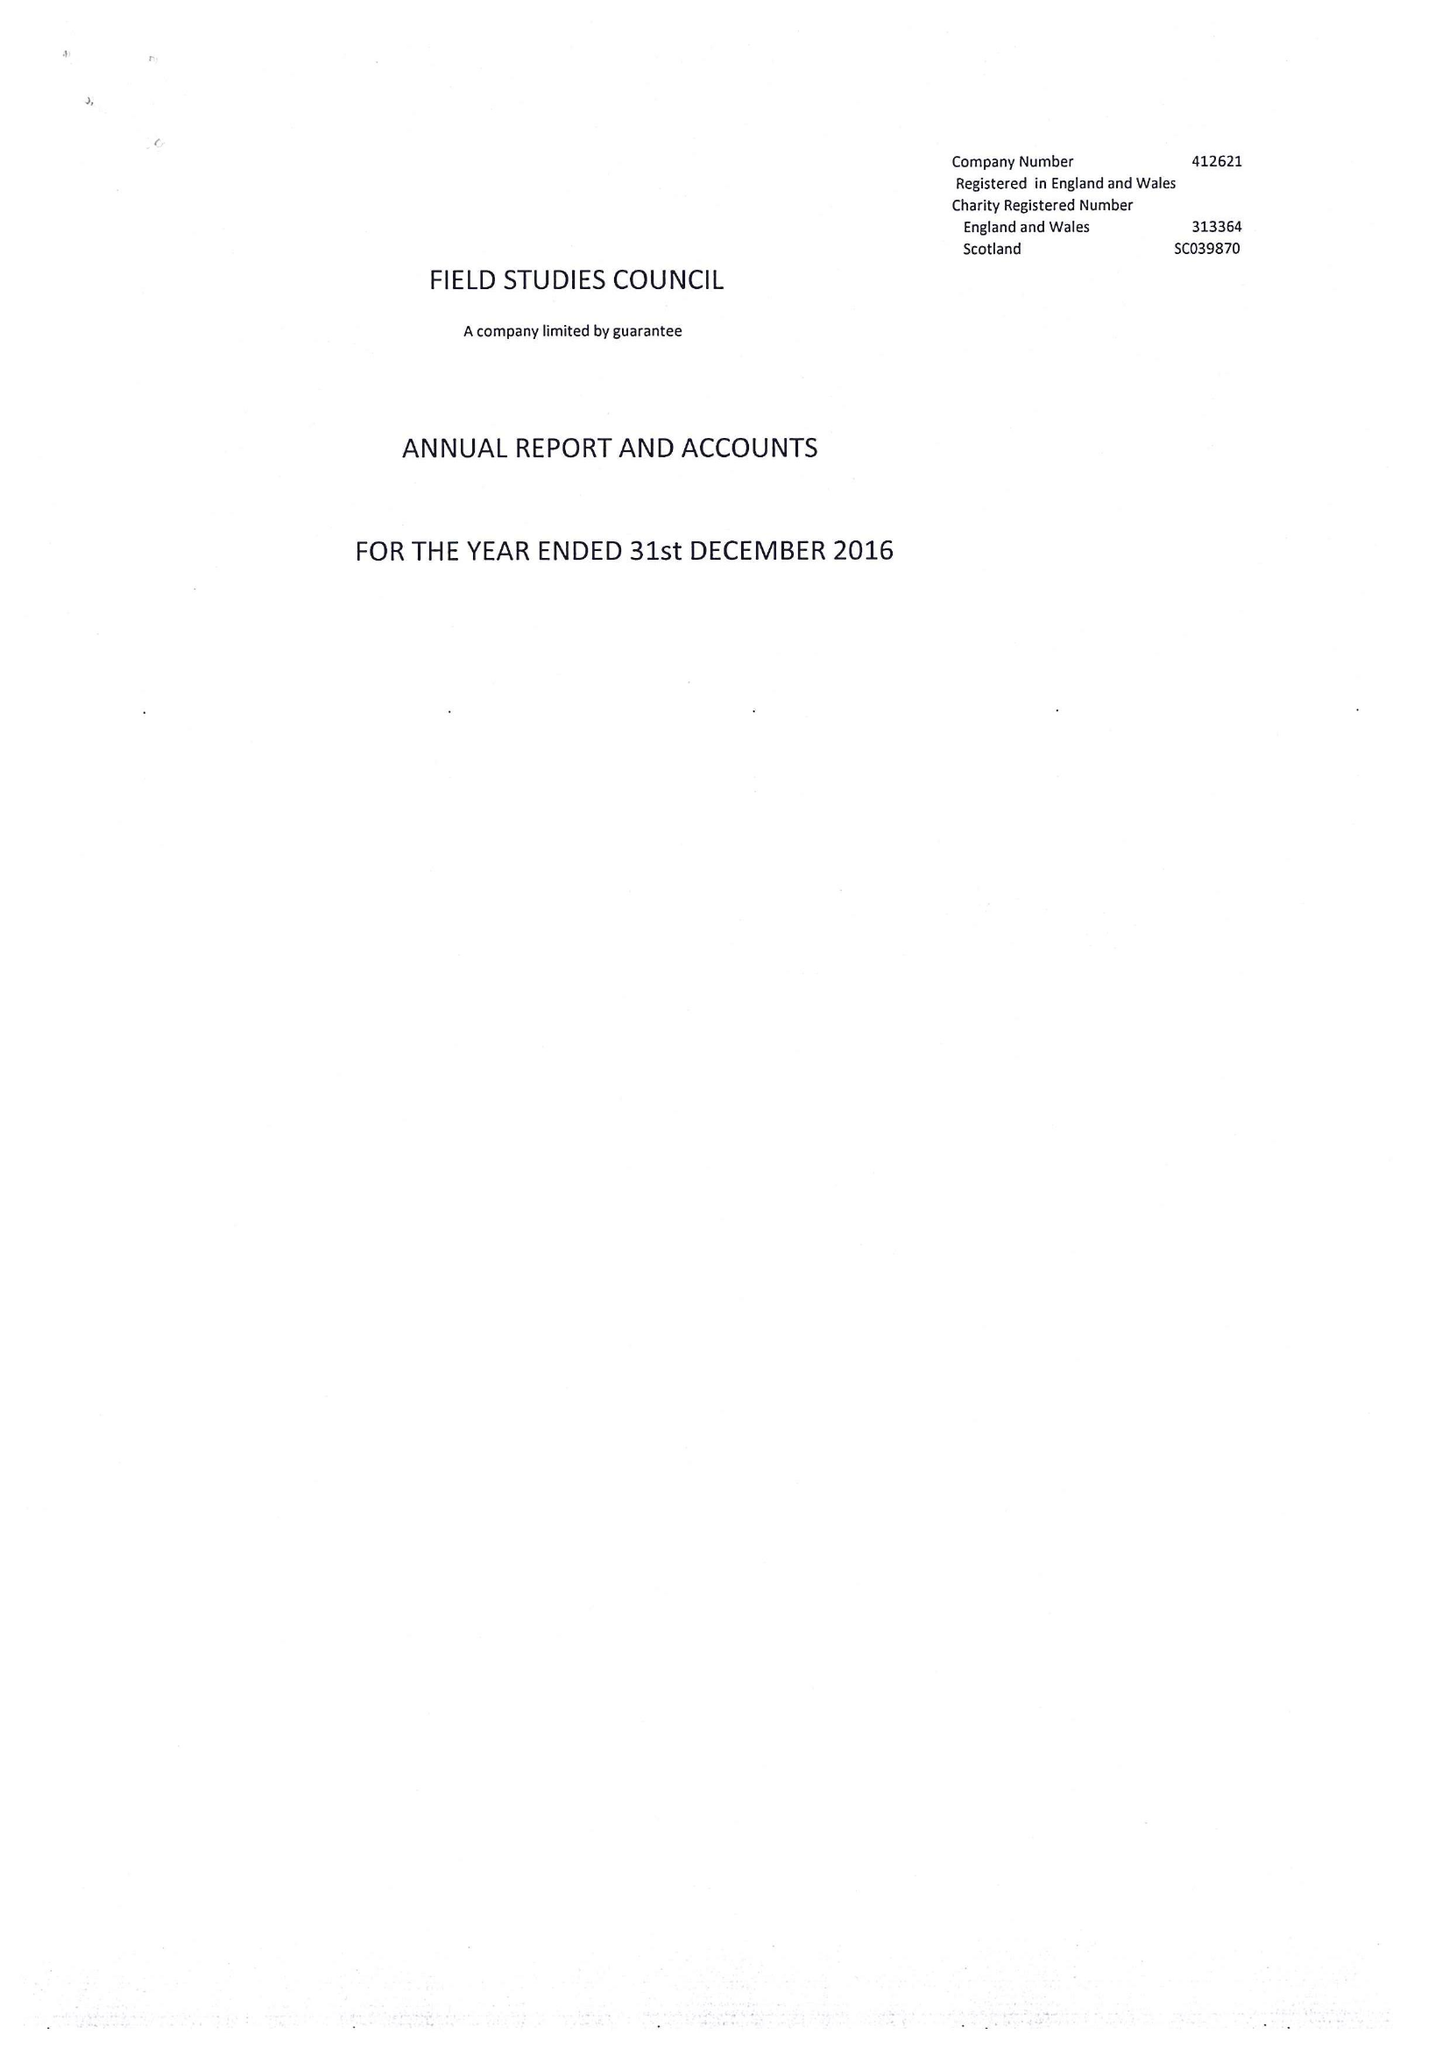What is the value for the address__postcode?
Answer the question using a single word or phrase. SY4 1HW 